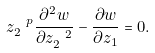Convert formula to latex. <formula><loc_0><loc_0><loc_500><loc_500>z _ { 2 } ^ { \ p } \frac { \partial ^ { 2 } w } { \partial z _ { 2 } ^ { \ 2 } } - \frac { \partial w } { \partial z _ { 1 } } = 0 .</formula> 